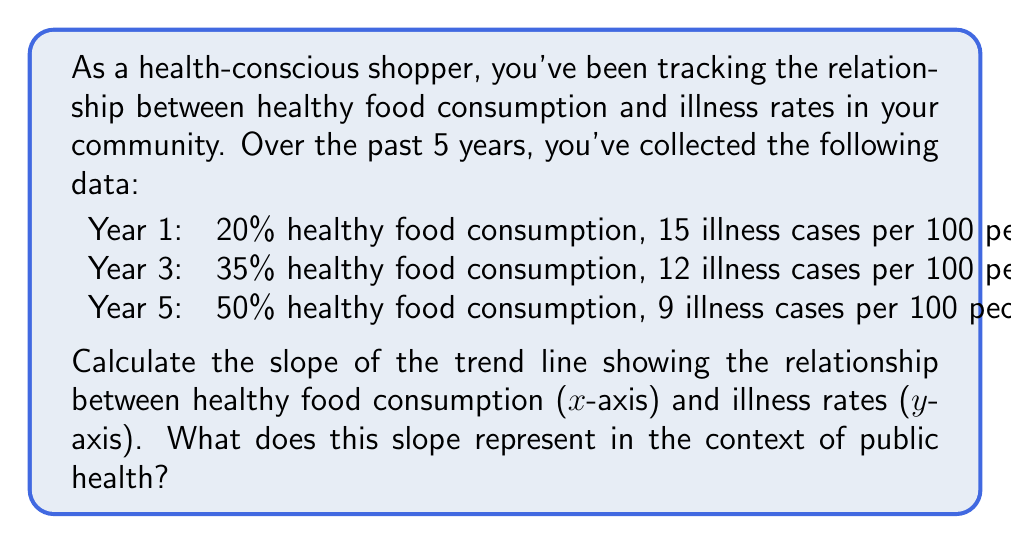Solve this math problem. To calculate the slope of the trend line, we'll use the point-slope formula:

$$ m = \frac{y_2 - y_1}{x_2 - x_1} $$

Where $m$ is the slope, $(x_1, y_1)$ and $(x_2, y_2)$ are two points on the line.

Let's use the data from Year 1 and Year 5:
$(x_1, y_1) = (20, 15)$
$(x_2, y_2) = (50, 9)$

Plugging these values into the formula:

$$ m = \frac{9 - 15}{50 - 20} = \frac{-6}{30} = -0.2 $$

The slope is -0.2, which represents the change in illness rates per unit change in healthy food consumption percentage.

To interpret this result:
For every 1% increase in healthy food consumption, there is a decrease of 0.2 illness cases per 100 people.

We can verify this slope using the other point (Year 3):
$$ \frac{12 - 15}{35 - 20} = \frac{-3}{15} = -0.2 $$

This confirms our calculated slope.
Answer: The slope of the trend line is -0.2 illness cases per 100 people per 1% increase in healthy food consumption. 